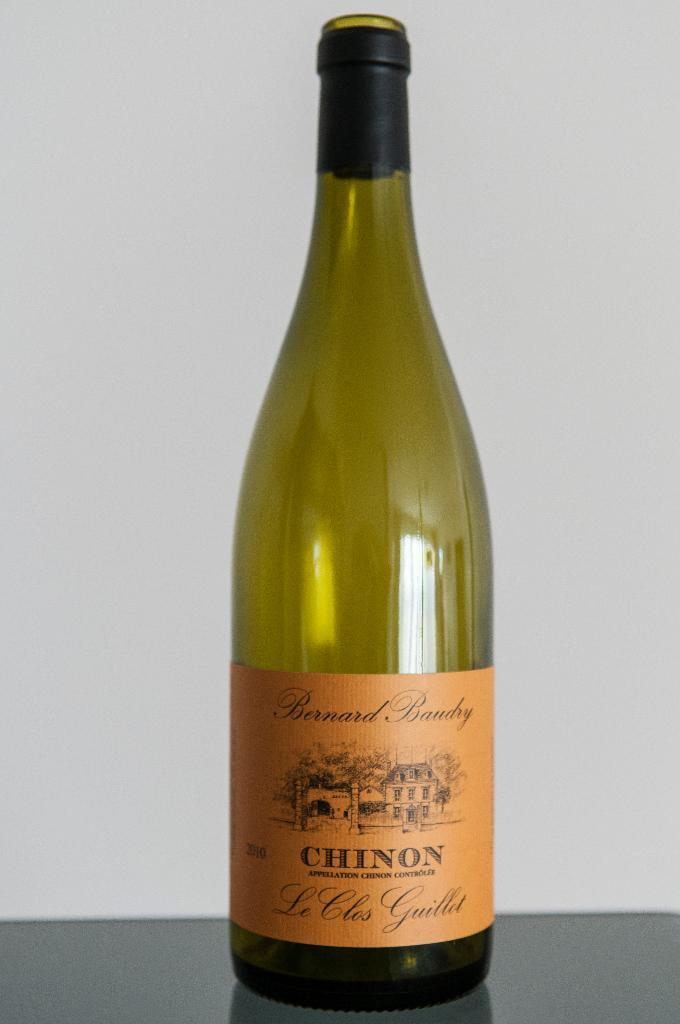<image>
Relay a brief, clear account of the picture shown. Bottle with an orange label that says CHINON on it. 